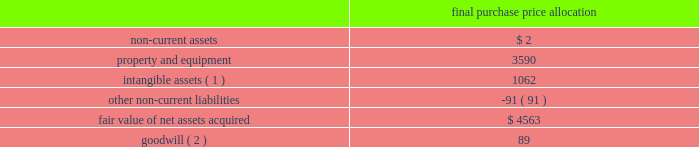American tower corporation and subsidiaries notes to consolidated financial statements the allocation of the purchase price was finalized during the year ended december 31 , 2012 .
The table summarizes the allocation of the aggregate purchase consideration paid and the amounts of assets acquired and liabilities assumed based upon their estimated fair value at the date of acquisition ( in thousands ) : purchase price allocation .
( 1 ) consists of customer-related intangibles of approximately $ 0.4 million and network location intangibles of approximately $ 0.7 million .
The customer-related intangibles and network location intangibles are being amortized on a straight-line basis over periods of up to 20 years .
( 2 ) the company expects that the goodwill recorded will be deductible for tax purposes .
The goodwill was allocated to the company 2019s international rental and management segment .
Colombia 2014colombia movil acquisition 2014on july 17 , 2011 , the company entered into a definitive agreement with colombia movil s.a .
E.s.p .
( 201ccolombia movil 201d ) , whereby atc sitios infraco , s.a.s. , a colombian subsidiary of the company ( 201catc infraco 201d ) , would purchase up to 2126 communications sites from colombia movil for an aggregate purchase price of approximately $ 182.0 million .
From december 21 , 2011 through the year ended december 31 , 2012 , atc infraco completed the purchase of 1526 communications sites for an aggregate purchase price of $ 136.2 million ( including contingent consideration of $ 17.3 million ) , subject to post-closing adjustments .
Through a subsidiary , millicom international cellular s.a .
( 201cmillicom 201d ) exercised its option to acquire an indirect , substantial non-controlling interest in atc infraco .
Under the terms of the agreement , the company is required to make additional payments upon the conversion of certain barter agreements with other wireless carriers to cash paying lease agreements .
Based on the company 2019s current estimates , the value of potential contingent consideration payments required to be made under the amended agreement is expected to be between zero and $ 32.8 million and is estimated to be $ 17.3 million using a probability weighted average of the expected outcomes at december 31 , 2012 .
During the year ended december 31 , 2012 , the company recorded a reduction in fair value of $ 1.2 million , which is included in other operating expenses in the consolidated statements of operations. .
What was the approximate purchase price for the unit communication sites from colombia movil? 
Computations: (182.0 / 2126)
Answer: 0.08561. 